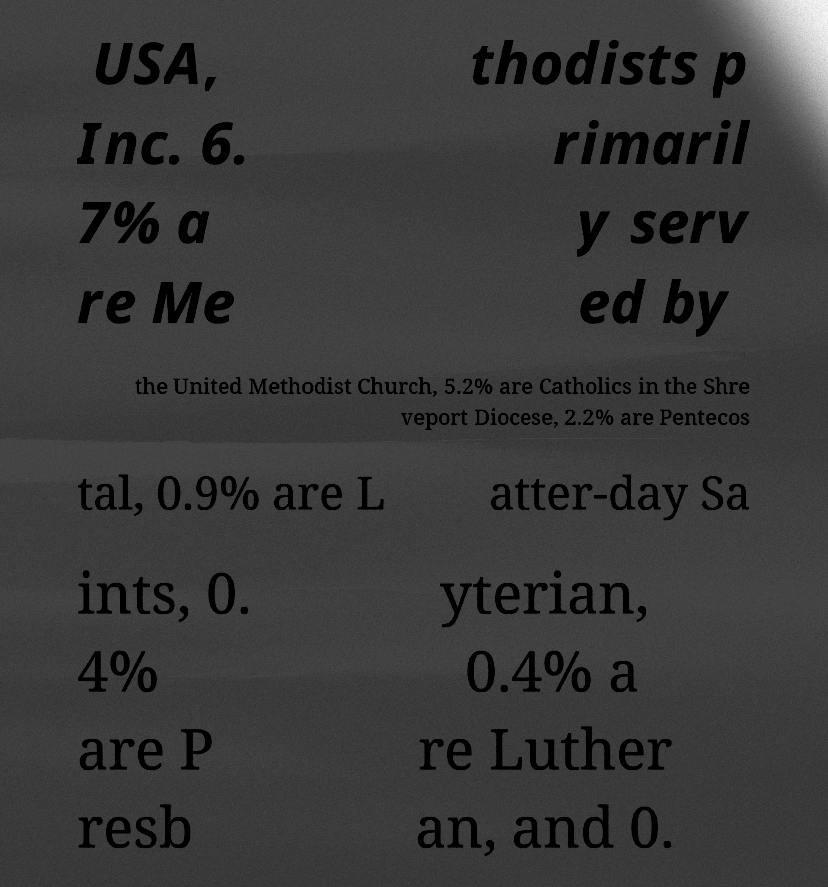Could you extract and type out the text from this image? USA, Inc. 6. 7% a re Me thodists p rimaril y serv ed by the United Methodist Church, 5.2% are Catholics in the Shre veport Diocese, 2.2% are Pentecos tal, 0.9% are L atter-day Sa ints, 0. 4% are P resb yterian, 0.4% a re Luther an, and 0. 